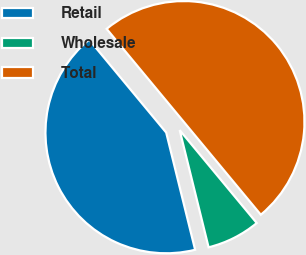<chart> <loc_0><loc_0><loc_500><loc_500><pie_chart><fcel>Retail<fcel>Wholesale<fcel>Total<nl><fcel>42.83%<fcel>7.17%<fcel>50.0%<nl></chart> 